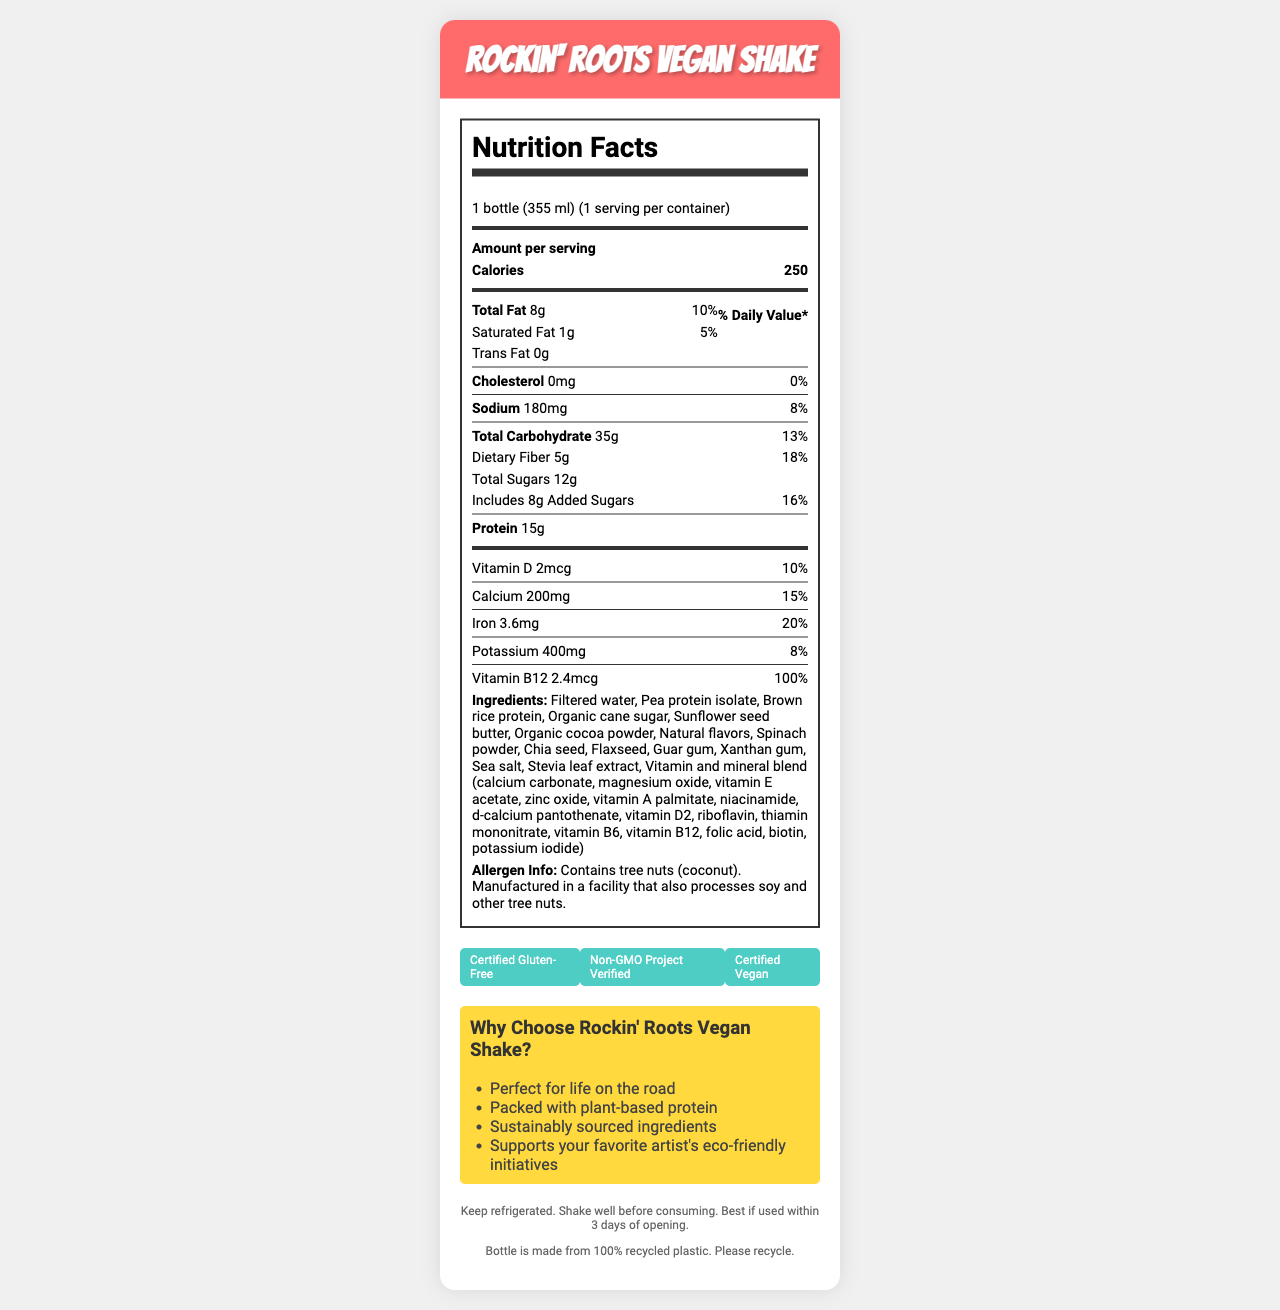What's the serving size of the Rockin' Roots Vegan Shake? The serving size is listed as "1 bottle (355 ml)" in the document.
Answer: 1 bottle (355 ml) How many calories are in one serving of the shake? The calories per serving are specified as 250 in the document.
Answer: 250 What percentage of the daily value of iron does one serving of this shake provide? The iron content per serving is listed as 3.6mg, which is 20% of the daily value.
Answer: 20% Does the Rockin' Roots Vegan Shake contain any trans fats? The document specifies that the trans fat content is 0g.
Answer: No What is the total carbohydrate content in the shake? The total carbohydrate per serving is listed as 35g.
Answer: 35g Which of the following vitamins is present at 100% of the daily value in the shake? 1. Vitamin B12 2. Vitamin D 3. Calcium 4. Iron The document lists Vitamin B12 at 100% of the daily value.
Answer: 1. Vitamin B12 Which ingredient is not part of the vitamin and mineral blend in the Rockin' Roots Vegan Shake? A. Calcium carbonate B. Magnesium oxide C. Organic cane sugar D. Vitamin B6 Organic cane sugar is listed separately from the vitamin and mineral blend.
Answer: C. Organic cane sugar Is the Rockin' Roots Vegan Shake suitable for vegans? The product is labeled as "Certified Vegan".
Answer: Yes Summarize the key nutritional and marketing points about the Rockin' Roots Vegan Shake. This shake includes 15g of protein, 5g of dietary fiber, and is fortified with vitamins and minerals such as Vitamin B12, calcium, and iron. The product also emphasizes sustainability and vegan certifications.
Answer: The Rockin' Roots Vegan Shake is a vegan, gluten-free meal replacement shake containing 250 calories per serving. It provides significant amounts of protein, dietary fiber, and several important vitamins and minerals, including Vitamin B12 at 100% of the daily value. It is noted for using sustainably sourced ingredients and supporting eco-friendly initiatives. What is the primary protein source in this shake? The first ingredient listed is "Pea protein isolate," indicating it is the primary protein source.
Answer: Pea protein isolate Does the document provide the production date of the shake? The document does not mention any production date information.
Answer: Not enough information What is the recommended action after opening the bottle? The document instructs to keep the bottle refrigerated and to consume it within 3 days of opening.
Answer: Keep refrigerated and consume within 3 days Are there any allergens mentioned in the shake's label? If yes, which ones? The allergen info states that the shake contains tree nuts (coconut) and is manufactured in a facility that processes soy and other tree nuts.
Answer: Yes, tree nuts (coconut) How much saturated fat is in one serving of the shake? The document lists the saturated fat content as 1g per serving.
Answer: 1g What type of sugar is added to the Rockin' Roots Vegan Shake? The ingredient list mentions "Organic cane sugar" as the added sugar.
Answer: Organic cane sugar What certification ensures that the shake is free from genetically modified organisms (GMOs)? One of the certifications listed is "Non-GMO Project Verified".
Answer: Non-GMO Project Verified 